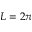Convert formula to latex. <formula><loc_0><loc_0><loc_500><loc_500>L = 2 \pi</formula> 